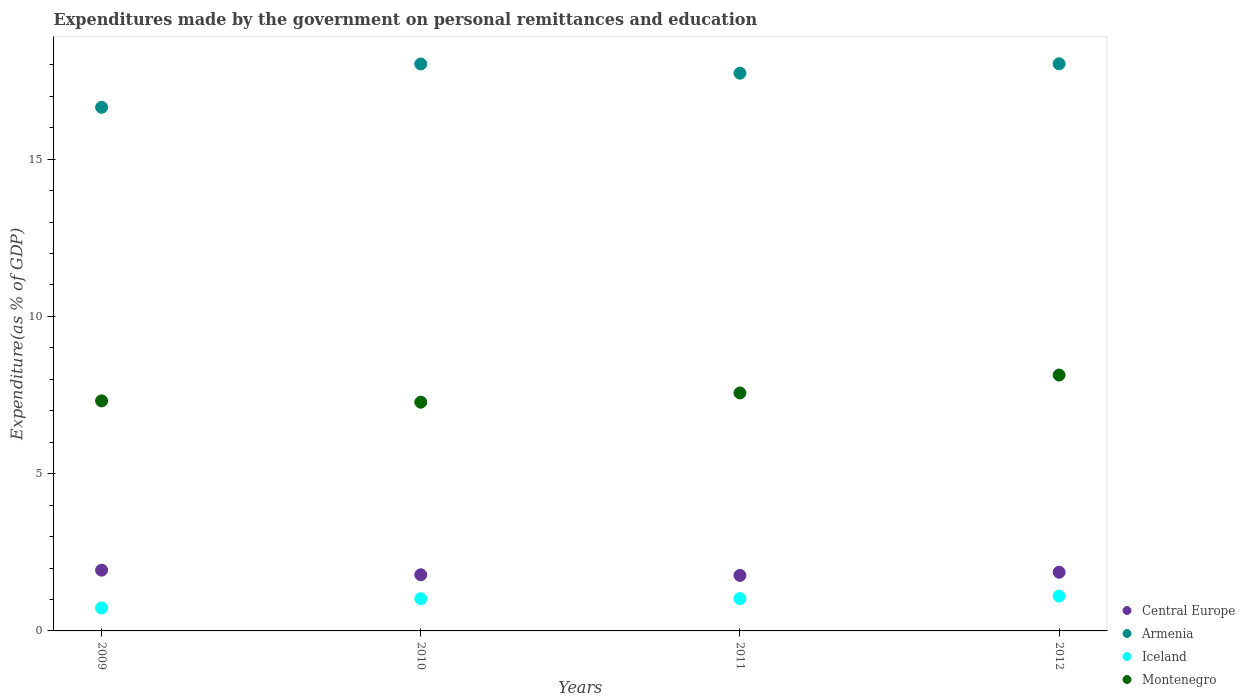How many different coloured dotlines are there?
Your answer should be very brief. 4. Is the number of dotlines equal to the number of legend labels?
Give a very brief answer. Yes. What is the expenditures made by the government on personal remittances and education in Iceland in 2012?
Give a very brief answer. 1.11. Across all years, what is the maximum expenditures made by the government on personal remittances and education in Central Europe?
Your answer should be compact. 1.93. Across all years, what is the minimum expenditures made by the government on personal remittances and education in Iceland?
Make the answer very short. 0.73. In which year was the expenditures made by the government on personal remittances and education in Iceland maximum?
Your response must be concise. 2012. In which year was the expenditures made by the government on personal remittances and education in Montenegro minimum?
Offer a terse response. 2010. What is the total expenditures made by the government on personal remittances and education in Central Europe in the graph?
Your response must be concise. 7.35. What is the difference between the expenditures made by the government on personal remittances and education in Central Europe in 2010 and that in 2011?
Provide a short and direct response. 0.02. What is the difference between the expenditures made by the government on personal remittances and education in Montenegro in 2011 and the expenditures made by the government on personal remittances and education in Iceland in 2009?
Offer a terse response. 6.84. What is the average expenditures made by the government on personal remittances and education in Armenia per year?
Your answer should be compact. 17.61. In the year 2012, what is the difference between the expenditures made by the government on personal remittances and education in Montenegro and expenditures made by the government on personal remittances and education in Central Europe?
Make the answer very short. 6.27. What is the ratio of the expenditures made by the government on personal remittances and education in Iceland in 2009 to that in 2011?
Offer a very short reply. 0.71. What is the difference between the highest and the second highest expenditures made by the government on personal remittances and education in Montenegro?
Keep it short and to the point. 0.57. What is the difference between the highest and the lowest expenditures made by the government on personal remittances and education in Montenegro?
Offer a terse response. 0.86. Is it the case that in every year, the sum of the expenditures made by the government on personal remittances and education in Iceland and expenditures made by the government on personal remittances and education in Montenegro  is greater than the sum of expenditures made by the government on personal remittances and education in Central Europe and expenditures made by the government on personal remittances and education in Armenia?
Your response must be concise. Yes. Is it the case that in every year, the sum of the expenditures made by the government on personal remittances and education in Armenia and expenditures made by the government on personal remittances and education in Central Europe  is greater than the expenditures made by the government on personal remittances and education in Iceland?
Your response must be concise. Yes. Does the expenditures made by the government on personal remittances and education in Armenia monotonically increase over the years?
Provide a succinct answer. No. What is the difference between two consecutive major ticks on the Y-axis?
Your response must be concise. 5. Are the values on the major ticks of Y-axis written in scientific E-notation?
Keep it short and to the point. No. Does the graph contain grids?
Make the answer very short. No. How many legend labels are there?
Your answer should be very brief. 4. What is the title of the graph?
Your response must be concise. Expenditures made by the government on personal remittances and education. What is the label or title of the Y-axis?
Make the answer very short. Expenditure(as % of GDP). What is the Expenditure(as % of GDP) in Central Europe in 2009?
Your response must be concise. 1.93. What is the Expenditure(as % of GDP) of Armenia in 2009?
Provide a short and direct response. 16.65. What is the Expenditure(as % of GDP) of Iceland in 2009?
Offer a very short reply. 0.73. What is the Expenditure(as % of GDP) in Montenegro in 2009?
Offer a terse response. 7.31. What is the Expenditure(as % of GDP) of Central Europe in 2010?
Make the answer very short. 1.78. What is the Expenditure(as % of GDP) of Armenia in 2010?
Your answer should be very brief. 18.03. What is the Expenditure(as % of GDP) in Iceland in 2010?
Your answer should be very brief. 1.02. What is the Expenditure(as % of GDP) of Montenegro in 2010?
Offer a very short reply. 7.27. What is the Expenditure(as % of GDP) of Central Europe in 2011?
Give a very brief answer. 1.76. What is the Expenditure(as % of GDP) of Armenia in 2011?
Make the answer very short. 17.73. What is the Expenditure(as % of GDP) of Iceland in 2011?
Make the answer very short. 1.03. What is the Expenditure(as % of GDP) in Montenegro in 2011?
Provide a succinct answer. 7.57. What is the Expenditure(as % of GDP) in Central Europe in 2012?
Provide a short and direct response. 1.87. What is the Expenditure(as % of GDP) of Armenia in 2012?
Ensure brevity in your answer.  18.03. What is the Expenditure(as % of GDP) in Iceland in 2012?
Provide a succinct answer. 1.11. What is the Expenditure(as % of GDP) of Montenegro in 2012?
Your answer should be compact. 8.14. Across all years, what is the maximum Expenditure(as % of GDP) of Central Europe?
Ensure brevity in your answer.  1.93. Across all years, what is the maximum Expenditure(as % of GDP) of Armenia?
Offer a terse response. 18.03. Across all years, what is the maximum Expenditure(as % of GDP) of Iceland?
Your answer should be compact. 1.11. Across all years, what is the maximum Expenditure(as % of GDP) in Montenegro?
Ensure brevity in your answer.  8.14. Across all years, what is the minimum Expenditure(as % of GDP) in Central Europe?
Your answer should be very brief. 1.76. Across all years, what is the minimum Expenditure(as % of GDP) of Armenia?
Keep it short and to the point. 16.65. Across all years, what is the minimum Expenditure(as % of GDP) of Iceland?
Your response must be concise. 0.73. Across all years, what is the minimum Expenditure(as % of GDP) of Montenegro?
Give a very brief answer. 7.27. What is the total Expenditure(as % of GDP) of Central Europe in the graph?
Provide a short and direct response. 7.35. What is the total Expenditure(as % of GDP) of Armenia in the graph?
Ensure brevity in your answer.  70.44. What is the total Expenditure(as % of GDP) in Iceland in the graph?
Keep it short and to the point. 3.89. What is the total Expenditure(as % of GDP) in Montenegro in the graph?
Your answer should be very brief. 30.29. What is the difference between the Expenditure(as % of GDP) of Central Europe in 2009 and that in 2010?
Provide a succinct answer. 0.15. What is the difference between the Expenditure(as % of GDP) of Armenia in 2009 and that in 2010?
Give a very brief answer. -1.38. What is the difference between the Expenditure(as % of GDP) of Iceland in 2009 and that in 2010?
Offer a terse response. -0.29. What is the difference between the Expenditure(as % of GDP) in Montenegro in 2009 and that in 2010?
Provide a short and direct response. 0.04. What is the difference between the Expenditure(as % of GDP) in Central Europe in 2009 and that in 2011?
Your answer should be very brief. 0.17. What is the difference between the Expenditure(as % of GDP) in Armenia in 2009 and that in 2011?
Your answer should be compact. -1.09. What is the difference between the Expenditure(as % of GDP) in Iceland in 2009 and that in 2011?
Give a very brief answer. -0.3. What is the difference between the Expenditure(as % of GDP) in Montenegro in 2009 and that in 2011?
Your answer should be compact. -0.25. What is the difference between the Expenditure(as % of GDP) of Central Europe in 2009 and that in 2012?
Ensure brevity in your answer.  0.07. What is the difference between the Expenditure(as % of GDP) in Armenia in 2009 and that in 2012?
Offer a terse response. -1.38. What is the difference between the Expenditure(as % of GDP) of Iceland in 2009 and that in 2012?
Offer a terse response. -0.38. What is the difference between the Expenditure(as % of GDP) of Montenegro in 2009 and that in 2012?
Offer a very short reply. -0.82. What is the difference between the Expenditure(as % of GDP) in Central Europe in 2010 and that in 2011?
Ensure brevity in your answer.  0.02. What is the difference between the Expenditure(as % of GDP) in Armenia in 2010 and that in 2011?
Make the answer very short. 0.29. What is the difference between the Expenditure(as % of GDP) in Iceland in 2010 and that in 2011?
Make the answer very short. -0.01. What is the difference between the Expenditure(as % of GDP) of Montenegro in 2010 and that in 2011?
Your answer should be very brief. -0.29. What is the difference between the Expenditure(as % of GDP) in Central Europe in 2010 and that in 2012?
Your response must be concise. -0.08. What is the difference between the Expenditure(as % of GDP) of Armenia in 2010 and that in 2012?
Give a very brief answer. -0.01. What is the difference between the Expenditure(as % of GDP) in Iceland in 2010 and that in 2012?
Provide a succinct answer. -0.08. What is the difference between the Expenditure(as % of GDP) in Montenegro in 2010 and that in 2012?
Offer a very short reply. -0.86. What is the difference between the Expenditure(as % of GDP) in Central Europe in 2011 and that in 2012?
Offer a very short reply. -0.1. What is the difference between the Expenditure(as % of GDP) in Armenia in 2011 and that in 2012?
Provide a short and direct response. -0.3. What is the difference between the Expenditure(as % of GDP) in Iceland in 2011 and that in 2012?
Give a very brief answer. -0.08. What is the difference between the Expenditure(as % of GDP) in Montenegro in 2011 and that in 2012?
Offer a terse response. -0.57. What is the difference between the Expenditure(as % of GDP) in Central Europe in 2009 and the Expenditure(as % of GDP) in Armenia in 2010?
Make the answer very short. -16.1. What is the difference between the Expenditure(as % of GDP) of Central Europe in 2009 and the Expenditure(as % of GDP) of Iceland in 2010?
Your answer should be very brief. 0.91. What is the difference between the Expenditure(as % of GDP) of Central Europe in 2009 and the Expenditure(as % of GDP) of Montenegro in 2010?
Ensure brevity in your answer.  -5.34. What is the difference between the Expenditure(as % of GDP) of Armenia in 2009 and the Expenditure(as % of GDP) of Iceland in 2010?
Keep it short and to the point. 15.63. What is the difference between the Expenditure(as % of GDP) of Armenia in 2009 and the Expenditure(as % of GDP) of Montenegro in 2010?
Provide a short and direct response. 9.38. What is the difference between the Expenditure(as % of GDP) of Iceland in 2009 and the Expenditure(as % of GDP) of Montenegro in 2010?
Offer a very short reply. -6.54. What is the difference between the Expenditure(as % of GDP) in Central Europe in 2009 and the Expenditure(as % of GDP) in Armenia in 2011?
Your response must be concise. -15.8. What is the difference between the Expenditure(as % of GDP) of Central Europe in 2009 and the Expenditure(as % of GDP) of Iceland in 2011?
Keep it short and to the point. 0.9. What is the difference between the Expenditure(as % of GDP) in Central Europe in 2009 and the Expenditure(as % of GDP) in Montenegro in 2011?
Provide a succinct answer. -5.64. What is the difference between the Expenditure(as % of GDP) of Armenia in 2009 and the Expenditure(as % of GDP) of Iceland in 2011?
Offer a very short reply. 15.62. What is the difference between the Expenditure(as % of GDP) of Armenia in 2009 and the Expenditure(as % of GDP) of Montenegro in 2011?
Provide a succinct answer. 9.08. What is the difference between the Expenditure(as % of GDP) of Iceland in 2009 and the Expenditure(as % of GDP) of Montenegro in 2011?
Offer a very short reply. -6.84. What is the difference between the Expenditure(as % of GDP) of Central Europe in 2009 and the Expenditure(as % of GDP) of Armenia in 2012?
Keep it short and to the point. -16.1. What is the difference between the Expenditure(as % of GDP) in Central Europe in 2009 and the Expenditure(as % of GDP) in Iceland in 2012?
Make the answer very short. 0.82. What is the difference between the Expenditure(as % of GDP) in Central Europe in 2009 and the Expenditure(as % of GDP) in Montenegro in 2012?
Offer a terse response. -6.21. What is the difference between the Expenditure(as % of GDP) in Armenia in 2009 and the Expenditure(as % of GDP) in Iceland in 2012?
Provide a short and direct response. 15.54. What is the difference between the Expenditure(as % of GDP) of Armenia in 2009 and the Expenditure(as % of GDP) of Montenegro in 2012?
Offer a very short reply. 8.51. What is the difference between the Expenditure(as % of GDP) in Iceland in 2009 and the Expenditure(as % of GDP) in Montenegro in 2012?
Provide a short and direct response. -7.41. What is the difference between the Expenditure(as % of GDP) in Central Europe in 2010 and the Expenditure(as % of GDP) in Armenia in 2011?
Provide a short and direct response. -15.95. What is the difference between the Expenditure(as % of GDP) in Central Europe in 2010 and the Expenditure(as % of GDP) in Iceland in 2011?
Provide a short and direct response. 0.76. What is the difference between the Expenditure(as % of GDP) in Central Europe in 2010 and the Expenditure(as % of GDP) in Montenegro in 2011?
Give a very brief answer. -5.78. What is the difference between the Expenditure(as % of GDP) of Armenia in 2010 and the Expenditure(as % of GDP) of Iceland in 2011?
Offer a very short reply. 17. What is the difference between the Expenditure(as % of GDP) in Armenia in 2010 and the Expenditure(as % of GDP) in Montenegro in 2011?
Make the answer very short. 10.46. What is the difference between the Expenditure(as % of GDP) of Iceland in 2010 and the Expenditure(as % of GDP) of Montenegro in 2011?
Keep it short and to the point. -6.54. What is the difference between the Expenditure(as % of GDP) in Central Europe in 2010 and the Expenditure(as % of GDP) in Armenia in 2012?
Offer a very short reply. -16.25. What is the difference between the Expenditure(as % of GDP) of Central Europe in 2010 and the Expenditure(as % of GDP) of Iceland in 2012?
Make the answer very short. 0.68. What is the difference between the Expenditure(as % of GDP) of Central Europe in 2010 and the Expenditure(as % of GDP) of Montenegro in 2012?
Make the answer very short. -6.35. What is the difference between the Expenditure(as % of GDP) in Armenia in 2010 and the Expenditure(as % of GDP) in Iceland in 2012?
Ensure brevity in your answer.  16.92. What is the difference between the Expenditure(as % of GDP) of Armenia in 2010 and the Expenditure(as % of GDP) of Montenegro in 2012?
Offer a very short reply. 9.89. What is the difference between the Expenditure(as % of GDP) in Iceland in 2010 and the Expenditure(as % of GDP) in Montenegro in 2012?
Your response must be concise. -7.11. What is the difference between the Expenditure(as % of GDP) in Central Europe in 2011 and the Expenditure(as % of GDP) in Armenia in 2012?
Offer a very short reply. -16.27. What is the difference between the Expenditure(as % of GDP) of Central Europe in 2011 and the Expenditure(as % of GDP) of Iceland in 2012?
Your answer should be very brief. 0.66. What is the difference between the Expenditure(as % of GDP) of Central Europe in 2011 and the Expenditure(as % of GDP) of Montenegro in 2012?
Provide a short and direct response. -6.37. What is the difference between the Expenditure(as % of GDP) of Armenia in 2011 and the Expenditure(as % of GDP) of Iceland in 2012?
Give a very brief answer. 16.63. What is the difference between the Expenditure(as % of GDP) in Armenia in 2011 and the Expenditure(as % of GDP) in Montenegro in 2012?
Keep it short and to the point. 9.6. What is the difference between the Expenditure(as % of GDP) in Iceland in 2011 and the Expenditure(as % of GDP) in Montenegro in 2012?
Offer a very short reply. -7.11. What is the average Expenditure(as % of GDP) in Central Europe per year?
Keep it short and to the point. 1.84. What is the average Expenditure(as % of GDP) of Armenia per year?
Your response must be concise. 17.61. What is the average Expenditure(as % of GDP) of Iceland per year?
Provide a succinct answer. 0.97. What is the average Expenditure(as % of GDP) of Montenegro per year?
Make the answer very short. 7.57. In the year 2009, what is the difference between the Expenditure(as % of GDP) in Central Europe and Expenditure(as % of GDP) in Armenia?
Make the answer very short. -14.72. In the year 2009, what is the difference between the Expenditure(as % of GDP) in Central Europe and Expenditure(as % of GDP) in Iceland?
Your answer should be very brief. 1.2. In the year 2009, what is the difference between the Expenditure(as % of GDP) in Central Europe and Expenditure(as % of GDP) in Montenegro?
Provide a short and direct response. -5.38. In the year 2009, what is the difference between the Expenditure(as % of GDP) in Armenia and Expenditure(as % of GDP) in Iceland?
Your response must be concise. 15.92. In the year 2009, what is the difference between the Expenditure(as % of GDP) in Armenia and Expenditure(as % of GDP) in Montenegro?
Keep it short and to the point. 9.33. In the year 2009, what is the difference between the Expenditure(as % of GDP) in Iceland and Expenditure(as % of GDP) in Montenegro?
Provide a short and direct response. -6.58. In the year 2010, what is the difference between the Expenditure(as % of GDP) of Central Europe and Expenditure(as % of GDP) of Armenia?
Your answer should be very brief. -16.24. In the year 2010, what is the difference between the Expenditure(as % of GDP) of Central Europe and Expenditure(as % of GDP) of Iceland?
Offer a very short reply. 0.76. In the year 2010, what is the difference between the Expenditure(as % of GDP) in Central Europe and Expenditure(as % of GDP) in Montenegro?
Make the answer very short. -5.49. In the year 2010, what is the difference between the Expenditure(as % of GDP) in Armenia and Expenditure(as % of GDP) in Iceland?
Provide a short and direct response. 17. In the year 2010, what is the difference between the Expenditure(as % of GDP) of Armenia and Expenditure(as % of GDP) of Montenegro?
Provide a succinct answer. 10.75. In the year 2010, what is the difference between the Expenditure(as % of GDP) in Iceland and Expenditure(as % of GDP) in Montenegro?
Provide a succinct answer. -6.25. In the year 2011, what is the difference between the Expenditure(as % of GDP) in Central Europe and Expenditure(as % of GDP) in Armenia?
Your answer should be compact. -15.97. In the year 2011, what is the difference between the Expenditure(as % of GDP) of Central Europe and Expenditure(as % of GDP) of Iceland?
Give a very brief answer. 0.74. In the year 2011, what is the difference between the Expenditure(as % of GDP) of Central Europe and Expenditure(as % of GDP) of Montenegro?
Ensure brevity in your answer.  -5.8. In the year 2011, what is the difference between the Expenditure(as % of GDP) in Armenia and Expenditure(as % of GDP) in Iceland?
Your answer should be compact. 16.71. In the year 2011, what is the difference between the Expenditure(as % of GDP) in Armenia and Expenditure(as % of GDP) in Montenegro?
Provide a short and direct response. 10.17. In the year 2011, what is the difference between the Expenditure(as % of GDP) in Iceland and Expenditure(as % of GDP) in Montenegro?
Your answer should be very brief. -6.54. In the year 2012, what is the difference between the Expenditure(as % of GDP) in Central Europe and Expenditure(as % of GDP) in Armenia?
Provide a succinct answer. -16.17. In the year 2012, what is the difference between the Expenditure(as % of GDP) of Central Europe and Expenditure(as % of GDP) of Iceland?
Offer a terse response. 0.76. In the year 2012, what is the difference between the Expenditure(as % of GDP) of Central Europe and Expenditure(as % of GDP) of Montenegro?
Your answer should be compact. -6.27. In the year 2012, what is the difference between the Expenditure(as % of GDP) of Armenia and Expenditure(as % of GDP) of Iceland?
Your response must be concise. 16.93. In the year 2012, what is the difference between the Expenditure(as % of GDP) in Armenia and Expenditure(as % of GDP) in Montenegro?
Offer a terse response. 9.9. In the year 2012, what is the difference between the Expenditure(as % of GDP) in Iceland and Expenditure(as % of GDP) in Montenegro?
Your answer should be compact. -7.03. What is the ratio of the Expenditure(as % of GDP) in Central Europe in 2009 to that in 2010?
Offer a terse response. 1.08. What is the ratio of the Expenditure(as % of GDP) of Armenia in 2009 to that in 2010?
Give a very brief answer. 0.92. What is the ratio of the Expenditure(as % of GDP) of Iceland in 2009 to that in 2010?
Keep it short and to the point. 0.71. What is the ratio of the Expenditure(as % of GDP) of Montenegro in 2009 to that in 2010?
Provide a short and direct response. 1.01. What is the ratio of the Expenditure(as % of GDP) in Central Europe in 2009 to that in 2011?
Provide a succinct answer. 1.09. What is the ratio of the Expenditure(as % of GDP) of Armenia in 2009 to that in 2011?
Offer a very short reply. 0.94. What is the ratio of the Expenditure(as % of GDP) in Iceland in 2009 to that in 2011?
Provide a short and direct response. 0.71. What is the ratio of the Expenditure(as % of GDP) of Montenegro in 2009 to that in 2011?
Offer a terse response. 0.97. What is the ratio of the Expenditure(as % of GDP) in Central Europe in 2009 to that in 2012?
Ensure brevity in your answer.  1.04. What is the ratio of the Expenditure(as % of GDP) of Armenia in 2009 to that in 2012?
Your answer should be very brief. 0.92. What is the ratio of the Expenditure(as % of GDP) in Iceland in 2009 to that in 2012?
Provide a succinct answer. 0.66. What is the ratio of the Expenditure(as % of GDP) of Montenegro in 2009 to that in 2012?
Give a very brief answer. 0.9. What is the ratio of the Expenditure(as % of GDP) of Central Europe in 2010 to that in 2011?
Provide a succinct answer. 1.01. What is the ratio of the Expenditure(as % of GDP) of Armenia in 2010 to that in 2011?
Offer a terse response. 1.02. What is the ratio of the Expenditure(as % of GDP) of Montenegro in 2010 to that in 2011?
Your response must be concise. 0.96. What is the ratio of the Expenditure(as % of GDP) of Central Europe in 2010 to that in 2012?
Give a very brief answer. 0.96. What is the ratio of the Expenditure(as % of GDP) in Armenia in 2010 to that in 2012?
Provide a succinct answer. 1. What is the ratio of the Expenditure(as % of GDP) of Iceland in 2010 to that in 2012?
Your answer should be compact. 0.92. What is the ratio of the Expenditure(as % of GDP) in Montenegro in 2010 to that in 2012?
Give a very brief answer. 0.89. What is the ratio of the Expenditure(as % of GDP) in Central Europe in 2011 to that in 2012?
Offer a terse response. 0.95. What is the ratio of the Expenditure(as % of GDP) of Armenia in 2011 to that in 2012?
Offer a very short reply. 0.98. What is the ratio of the Expenditure(as % of GDP) of Iceland in 2011 to that in 2012?
Make the answer very short. 0.93. What is the ratio of the Expenditure(as % of GDP) of Montenegro in 2011 to that in 2012?
Your answer should be very brief. 0.93. What is the difference between the highest and the second highest Expenditure(as % of GDP) of Central Europe?
Offer a terse response. 0.07. What is the difference between the highest and the second highest Expenditure(as % of GDP) of Armenia?
Offer a very short reply. 0.01. What is the difference between the highest and the second highest Expenditure(as % of GDP) in Iceland?
Your answer should be compact. 0.08. What is the difference between the highest and the second highest Expenditure(as % of GDP) in Montenegro?
Make the answer very short. 0.57. What is the difference between the highest and the lowest Expenditure(as % of GDP) of Central Europe?
Offer a terse response. 0.17. What is the difference between the highest and the lowest Expenditure(as % of GDP) in Armenia?
Your answer should be compact. 1.38. What is the difference between the highest and the lowest Expenditure(as % of GDP) in Iceland?
Provide a succinct answer. 0.38. What is the difference between the highest and the lowest Expenditure(as % of GDP) in Montenegro?
Offer a terse response. 0.86. 